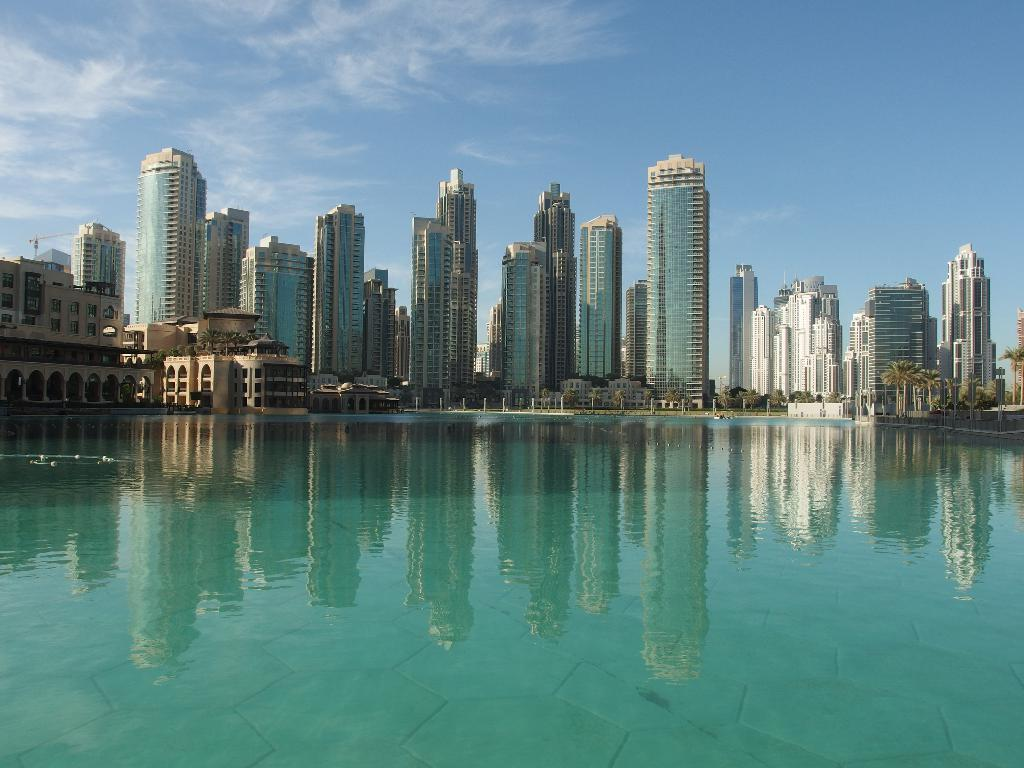What type of natural feature can be seen in the image? There is a lake in the image. What man-made structures are present in the image? There are buildings in the image. What objects are standing upright in the image? There are poles in the image. What type of vegetation is present in the image? There are trees in the image. What is visible above the land and water in the image? The sky is visible in the image. What atmospheric conditions can be observed in the sky? There are clouds in the sky. What type of juice is being served to the parent in the image? There is no parent or juice present in the image. 